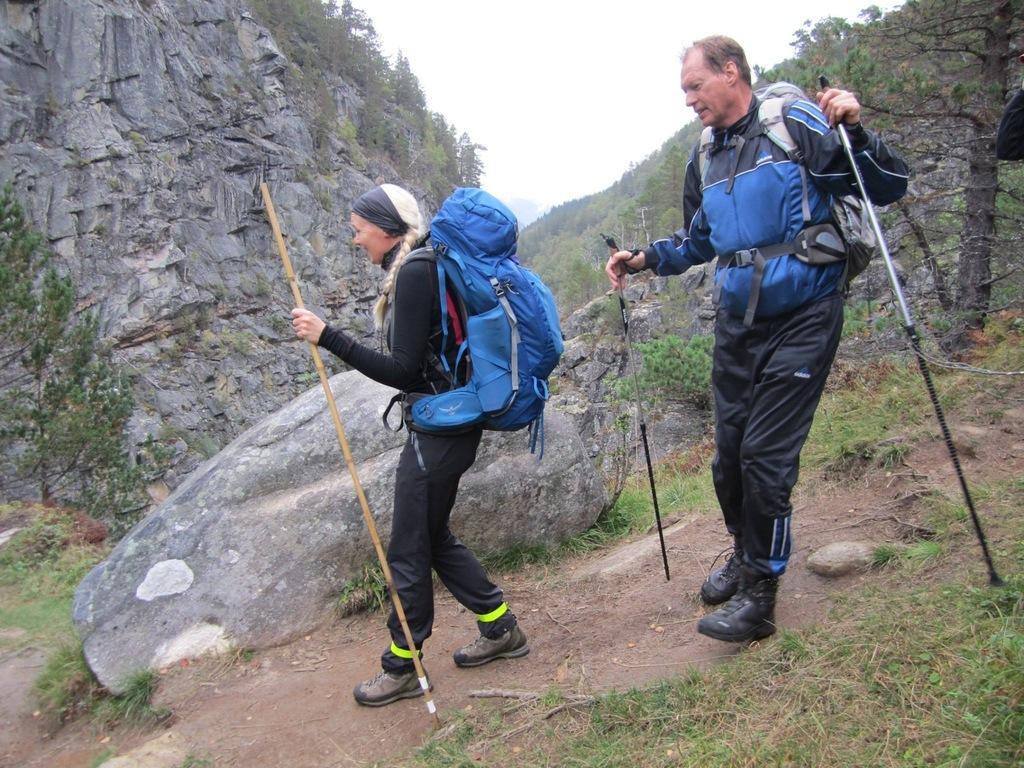How would you summarize this image in a sentence or two? These people wore bags and holding sticks. In this image we can see a mountain, rocks, grass and trees. Background there is a sky.   